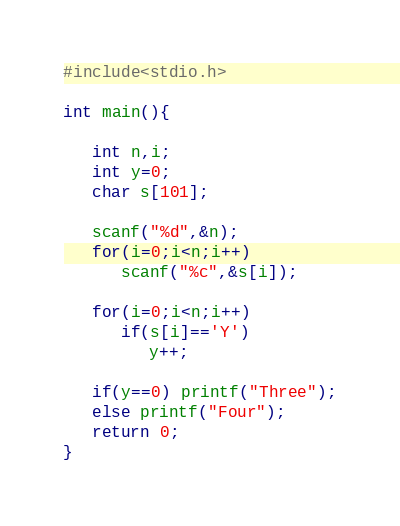<code> <loc_0><loc_0><loc_500><loc_500><_C_>#include<stdio.h>

int main(){

   int n,i;
   int y=0;
   char s[101];

   scanf("%d",&n);
   for(i=0;i<n;i++)
      scanf("%c",&s[i]);

   for(i=0;i<n;i++)
      if(s[i]=='Y')
         y++;

   if(y==0) printf("Three");
   else printf("Four");
   return 0;
}
</code> 